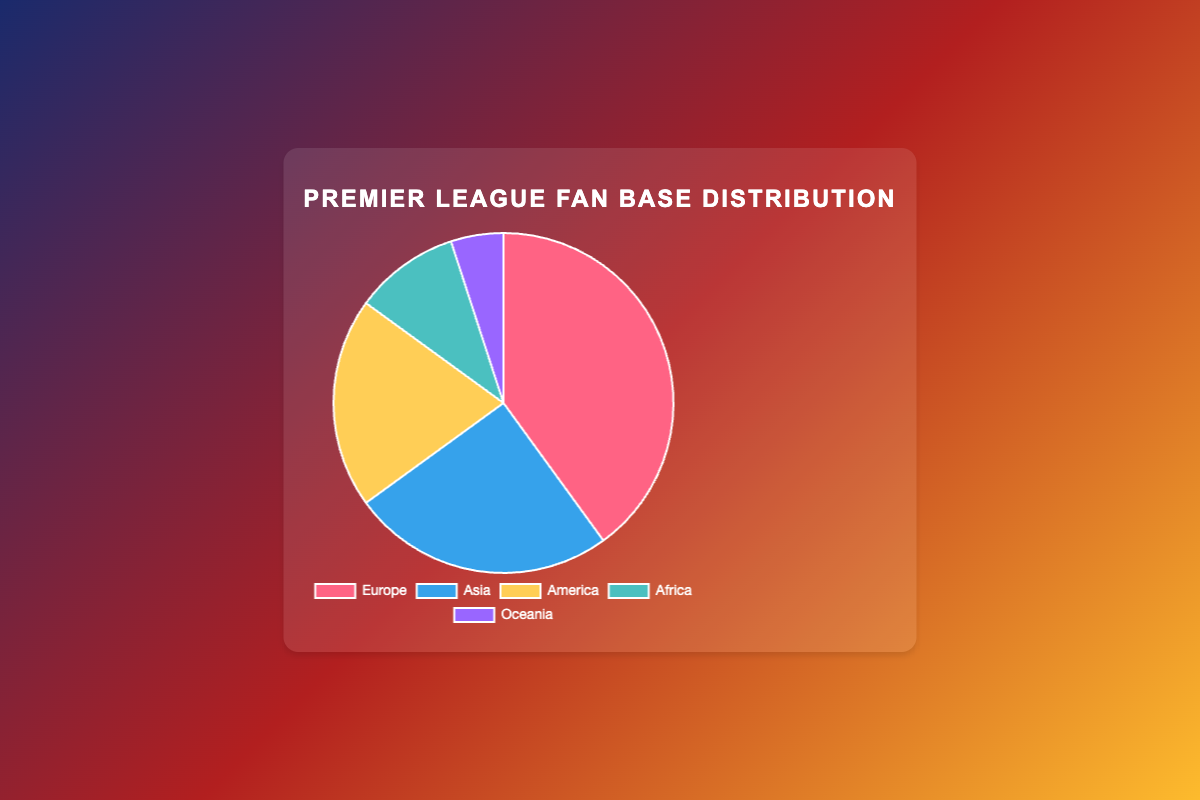What percentage of the fan base is from Africa? The pie chart shows that Africa accounts for 10% of the Premier League fan base.
Answer: 10% Which continent has the highest fan base percentage? The continent with the highest fan base percentage is Europe, which has 40% of the fans.
Answer: Europe What is the difference in fan base percentage between Asia and Oceania? Asia has 25% and Oceania has 5%. The difference is 25% - 5% = 20%.
Answer: 20% Which two continents together make up 30% of the fan base? Both Africa and Oceania combined have 15% (10% + 5%). The next smallest percentage is America, which added to Africa (10%) equals 30%.
Answer: Africa and America Is the fan base in Europe more than twice that of Asia? The fan base in Europe is 40%, and twice that of Asia (25%) is 50%. 40% is not more than 50%.
Answer: No List the continents in descending order of fan base percentage. Europe: 40%, Asia: 25%, America: 20%, Africa: 10%, Oceania: 5%.
Answer: Europe, Asia, America, Africa, Oceania By how much does the American fan base exceed the African fan base? The American fan base is 20%, while the African fan base is 10%. The difference is 20% - 10% = 10%.
Answer: 10% What percentage of the fan base is not from Europe? The total fan base percentage is 100%. Europe contributes 40%, so the remaining is 100% - 40% = 60%.
Answer: 60% If you combine the fan bases of Oceania and Africa, is it more than that of America alone? Oceania and Africa together have 5% + 10% = 15%. America alone has 20%, which is more than 15%.
Answer: No What color represents the Asian fan base in the pie chart? The chart shows that the color representing the Asian fan base is blue.
Answer: Blue 